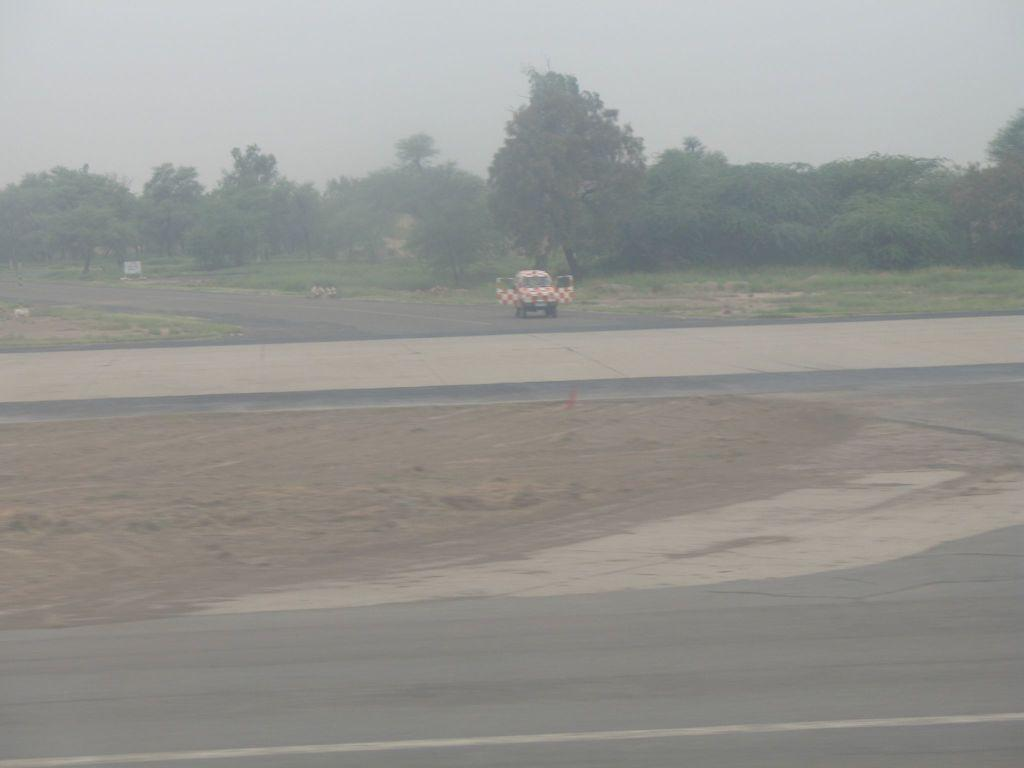What type of natural environment is depicted in the image? The image contains grass, plants, and trees, which are all elements of a natural environment. What type of man-made object is present in the image? There is a vehicle in the image. What can be seen in the background of the image? The sky is visible in the background of the image. Where are the children performing on the stage in the image? There are no children or stage present in the image. What type of feather can be seen on the tree in the image? There is no feather visible on the trees in the image. 